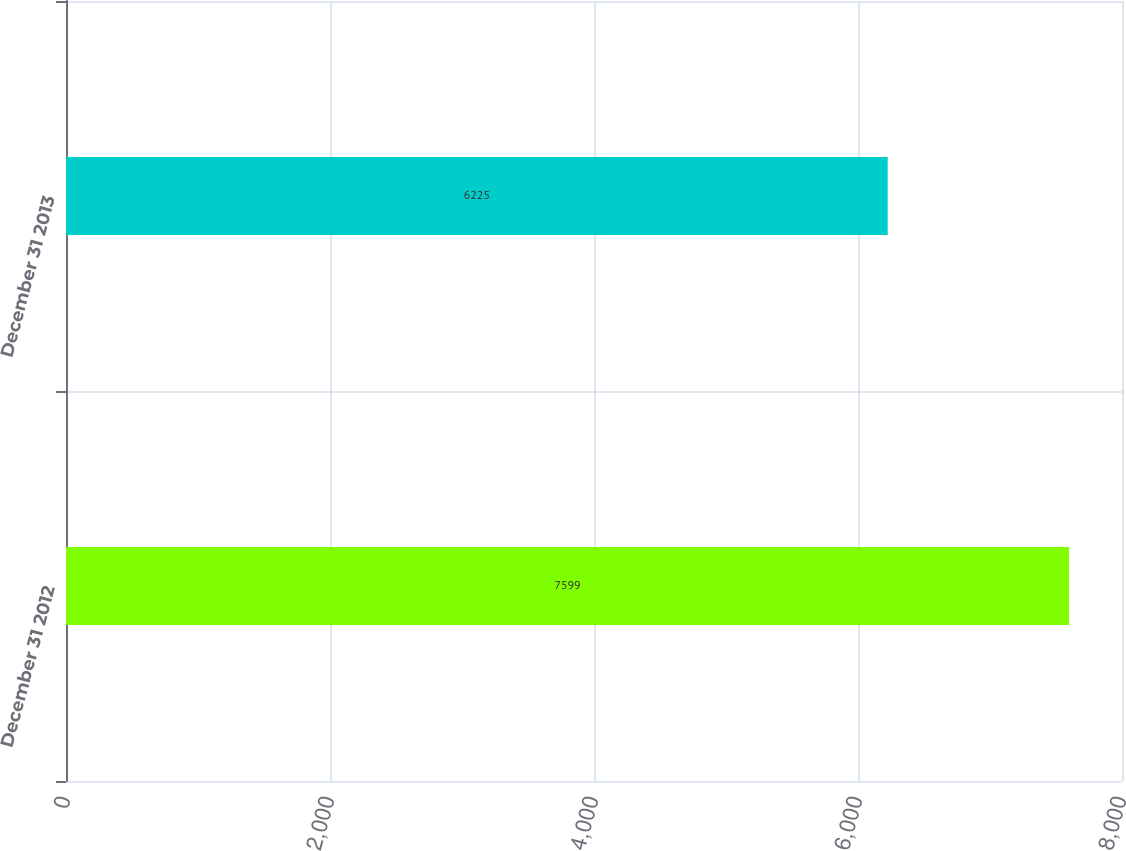Convert chart. <chart><loc_0><loc_0><loc_500><loc_500><bar_chart><fcel>December 31 2012<fcel>December 31 2013<nl><fcel>7599<fcel>6225<nl></chart> 